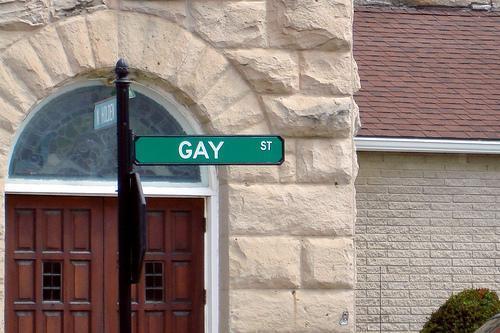How many arches are there?
Give a very brief answer. 1. How many street signs are in the picture?
Give a very brief answer. 1. How many windows are in this image?
Give a very brief answer. 1. 